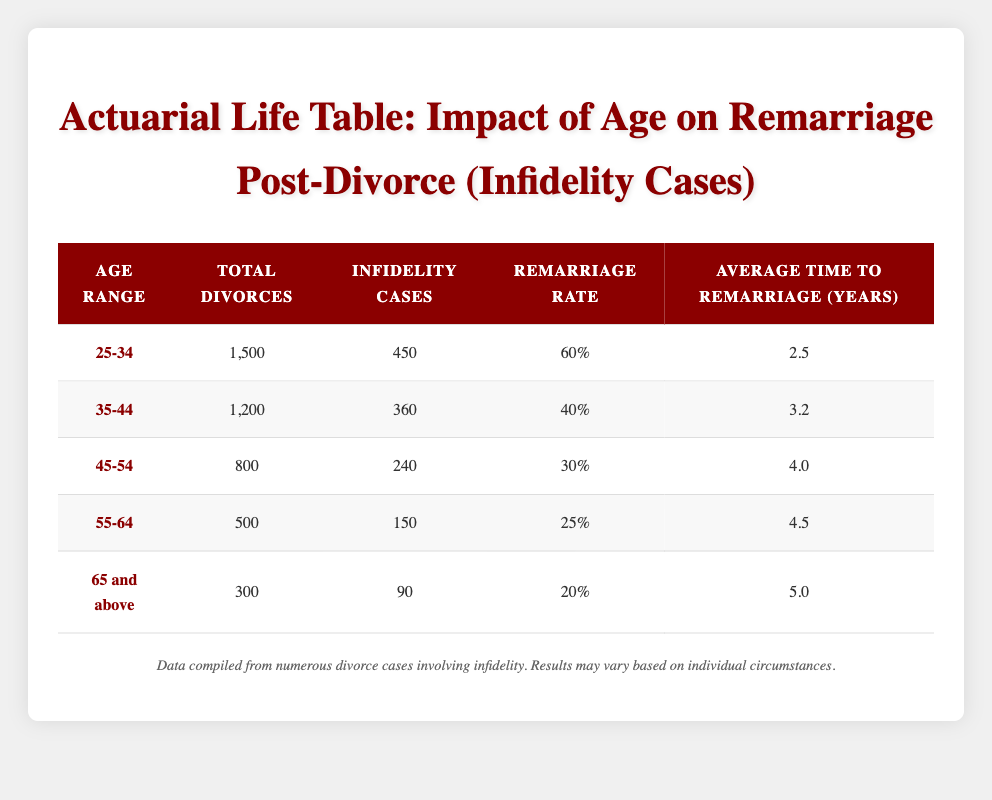What is the remarrying rate for individuals aged 25-34? The table shows a column for "Remarriage Rate" under the age range "25-34," and the value listed is 0.6, which can also be expressed as 60%.
Answer: 60% How many total divorces occurred for individuals aged 35-44? In the "Total Divorces" column, the value listed for the age range "35-44" is 1200.
Answer: 1200 Is the average time to remarriage higher for the age group 55-64 than for the age group 45-54? The average time to remarriage for "55-64" is 4.5 years, while for "45-54" it is 4.0 years. Since 4.5 > 4.0, the statement is true.
Answer: Yes What is the combined number of infidelity cases for individuals aged 35-44 and 45-54? The table presents 360 infidelity cases for "35-44" and 240 for "45-54." Adding these values: 360 + 240 = 600 gives the total.
Answer: 600 For which age group is the highest remarriage rate observed? The table indicates that the highest remarriage rate of 60% is for the age group "25-34," which can be seen in the "Remarriage Rate" column.
Answer: 25-34 Which age group has the lowest total divorces and what is that number? By examining the "Total Divorces" column, the age group "65 and above" has the lowest total, which is 300.
Answer: 300 What is the difference in average time to remarriage between the 25-34 age group and the 65 and above age group? The average time to remarriage for "25-34" is 2.5 years, and for "65 and above," it is 5.0 years. Calculating the difference: 5.0 - 2.5 = 2.5 years.
Answer: 2.5 Does the age group 45-54 have a higher percentage of infidelity cases compared to the age group 55-64? The table shows that "45-54" has 240 infidelity cases out of 800 total divorces (30%) while "55-64" has 150 out of 500 total divorces (30%). Therefore, their percentages are equal.
Answer: No If an individual is aged 55-64, what is their probability of remarrying after divorce? The probability or remarrying rate for the age group "55-64" from the table is listed as 0.25, equivalent to 25%.
Answer: 25% 